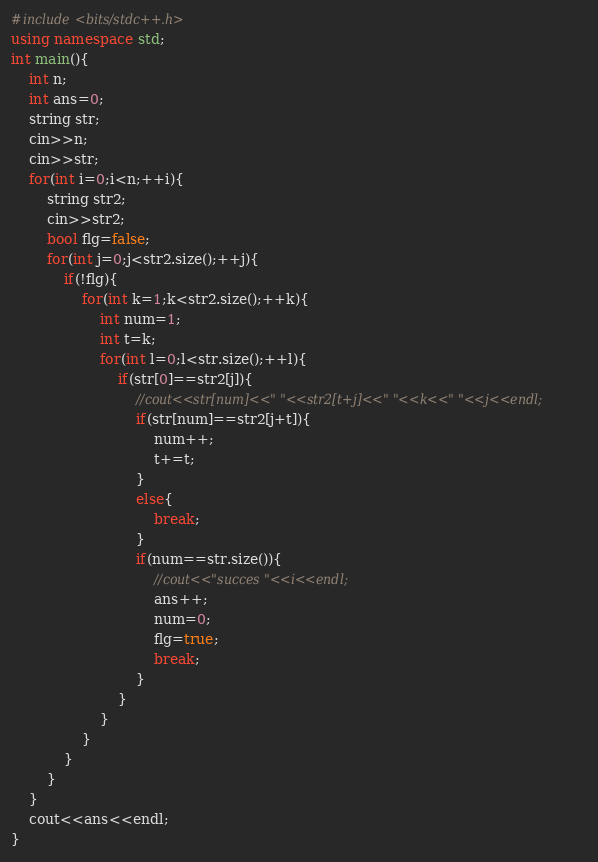<code> <loc_0><loc_0><loc_500><loc_500><_C++_>#include<bits/stdc++.h>
using namespace std;
int main(){
    int n;
    int ans=0;
    string str;
    cin>>n;
    cin>>str;
    for(int i=0;i<n;++i){
        string str2;
        cin>>str2;
        bool flg=false;
        for(int j=0;j<str2.size();++j){
            if(!flg){
                for(int k=1;k<str2.size();++k){
                    int num=1;
                    int t=k;
                    for(int l=0;l<str.size();++l){
                        if(str[0]==str2[j]){
                            //cout<<str[num]<<" "<<str2[t+j]<<" "<<k<<" "<<j<<endl;
                            if(str[num]==str2[j+t]){
                                num++;
                                t+=t;
                            }
                            else{
                                break;
                            }
                            if(num==str.size()){
                                //cout<<"succes "<<i<<endl;
                                ans++;
                                num=0;
                                flg=true;
                                break;
                            }
                        }
                    }
                }
            }
        }
    }
    cout<<ans<<endl;
}</code> 